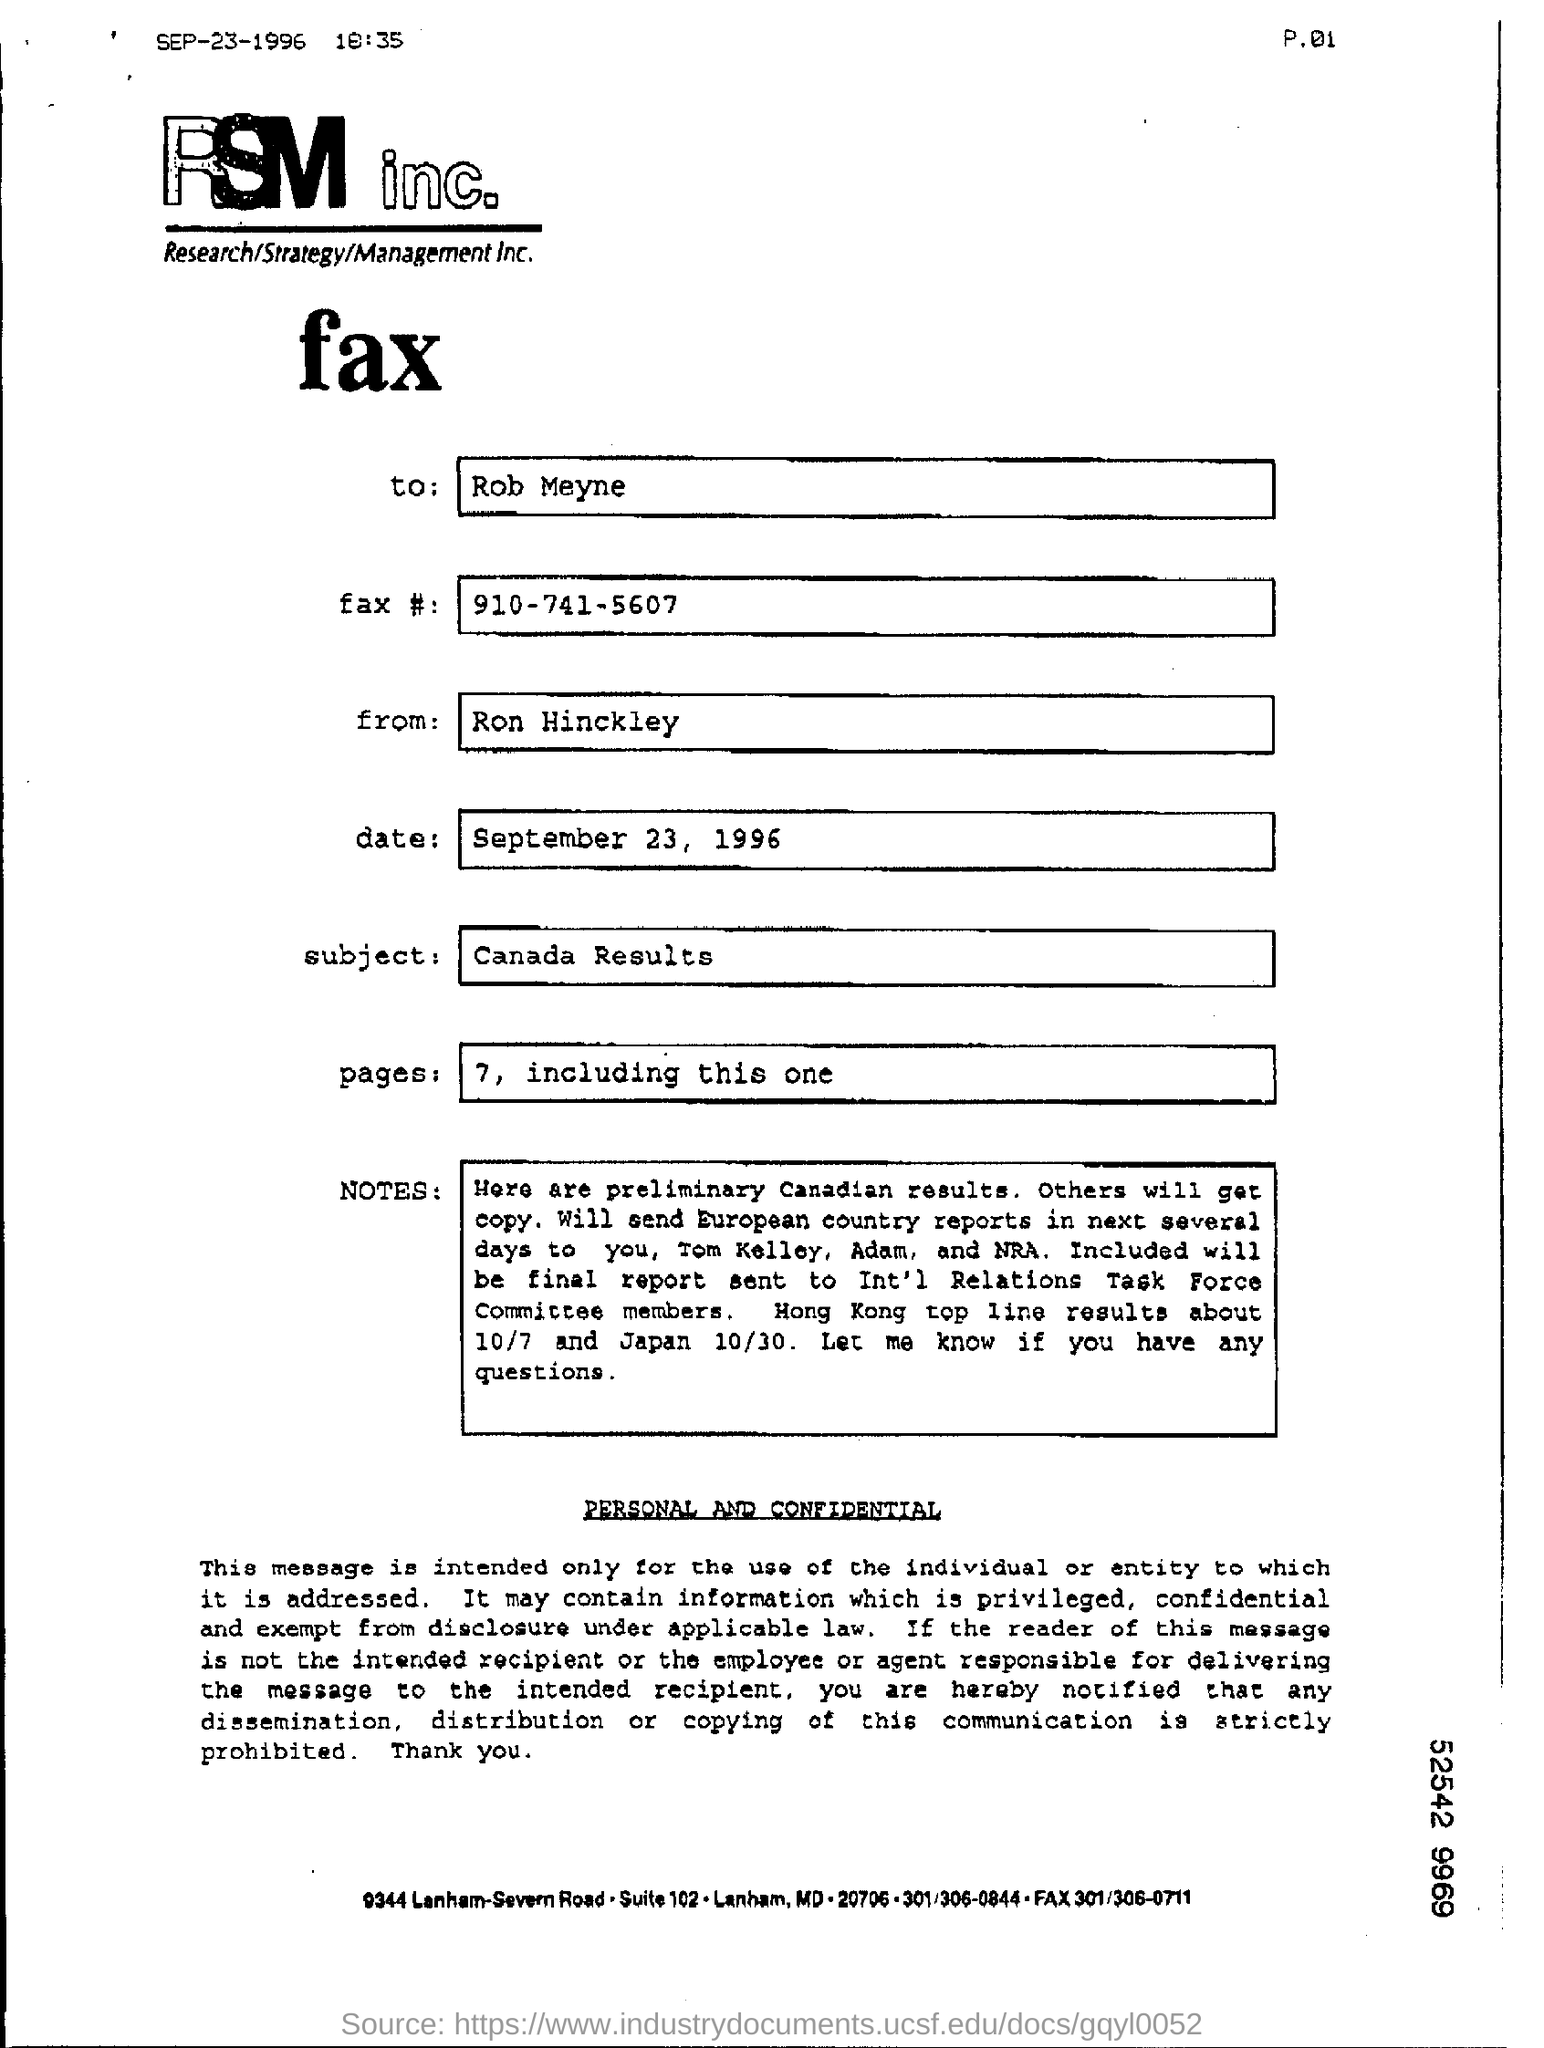Specify some key components in this picture. The sender of the fax is Ron Hinckley. The fax is being sent to the recipient named "Rob Meyne. The subject mentioned in the fax is Canada Results. What is the fax number given? It is 910-741-5607. The date mentioned in the fax is September 23, 1996. 